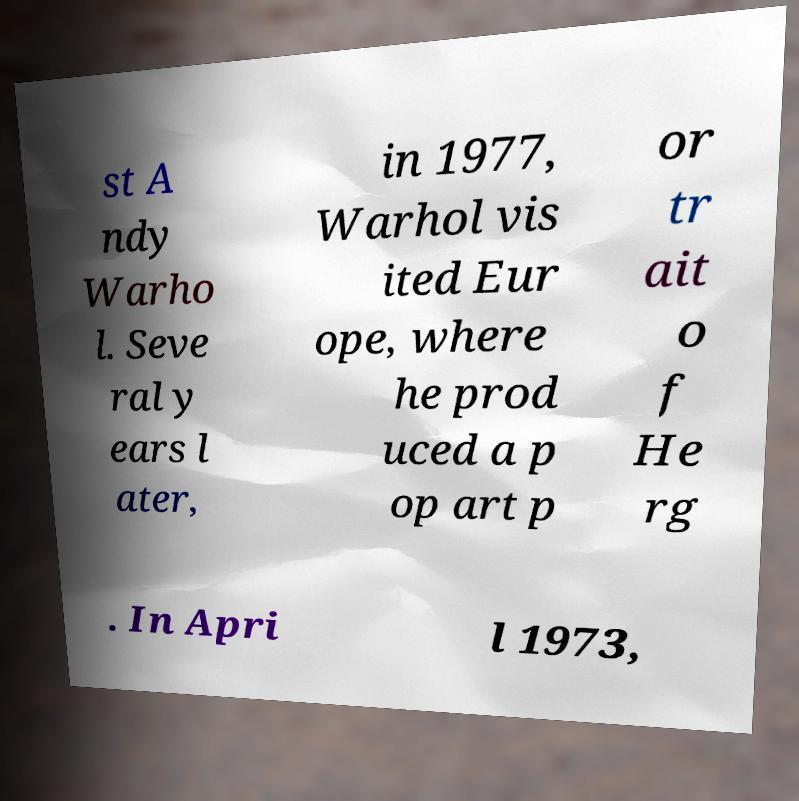There's text embedded in this image that I need extracted. Can you transcribe it verbatim? st A ndy Warho l. Seve ral y ears l ater, in 1977, Warhol vis ited Eur ope, where he prod uced a p op art p or tr ait o f He rg . In Apri l 1973, 